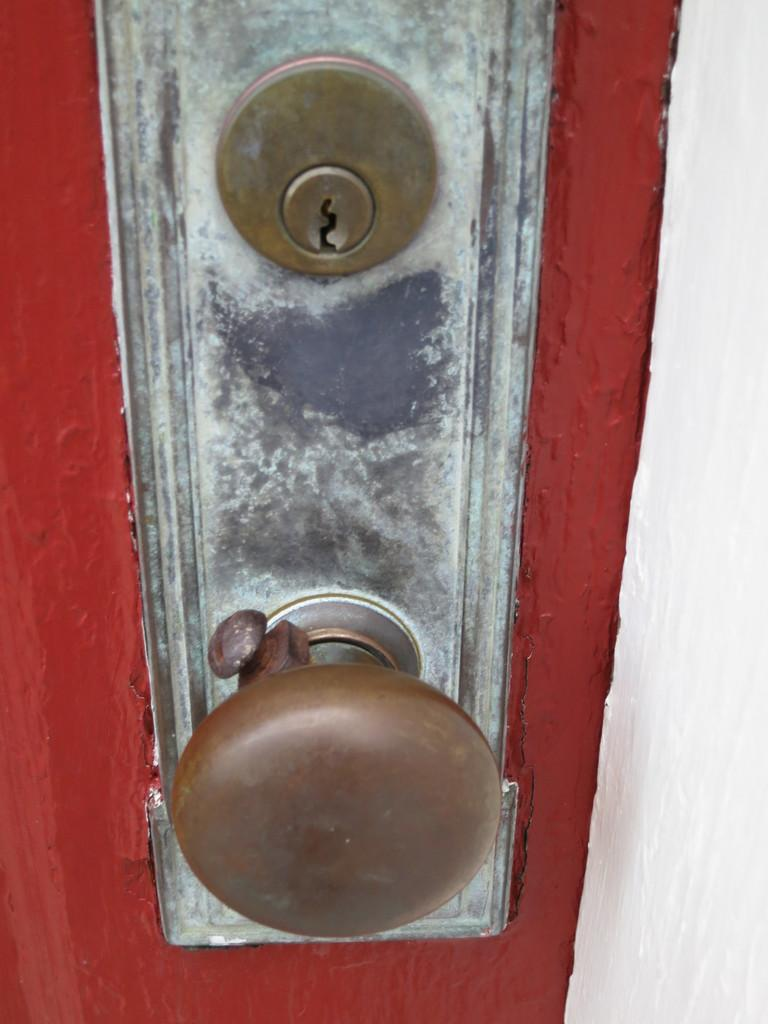What type of structure can be seen in the image? There is a door and a wall in the image. What other object is present in the image? There is a locker in the image. Where might this image have been taken? The image may have been taken in a house. What type of game is being played in the image? There is no game being played in the image; it only features a door, a wall, and a locker. What condition is the station in the image? There is no station present in the image, so it is not possible to determine its condition. 